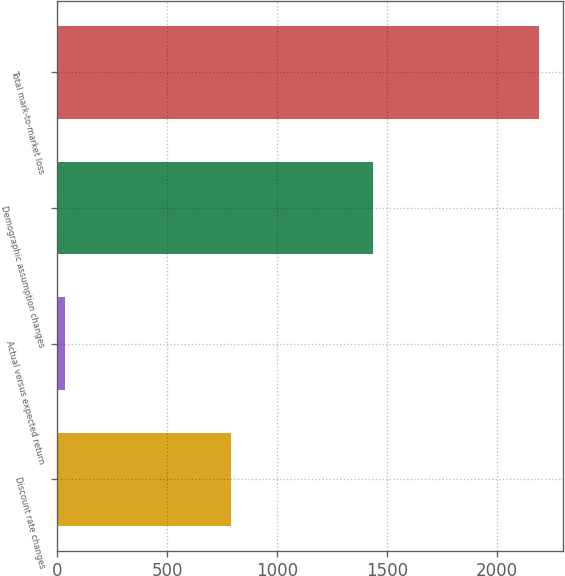Convert chart to OTSL. <chart><loc_0><loc_0><loc_500><loc_500><bar_chart><fcel>Discount rate changes<fcel>Actual versus expected return<fcel>Demographic assumption changes<fcel>Total mark-to-market loss<nl><fcel>791<fcel>35<fcel>1434<fcel>2190<nl></chart> 